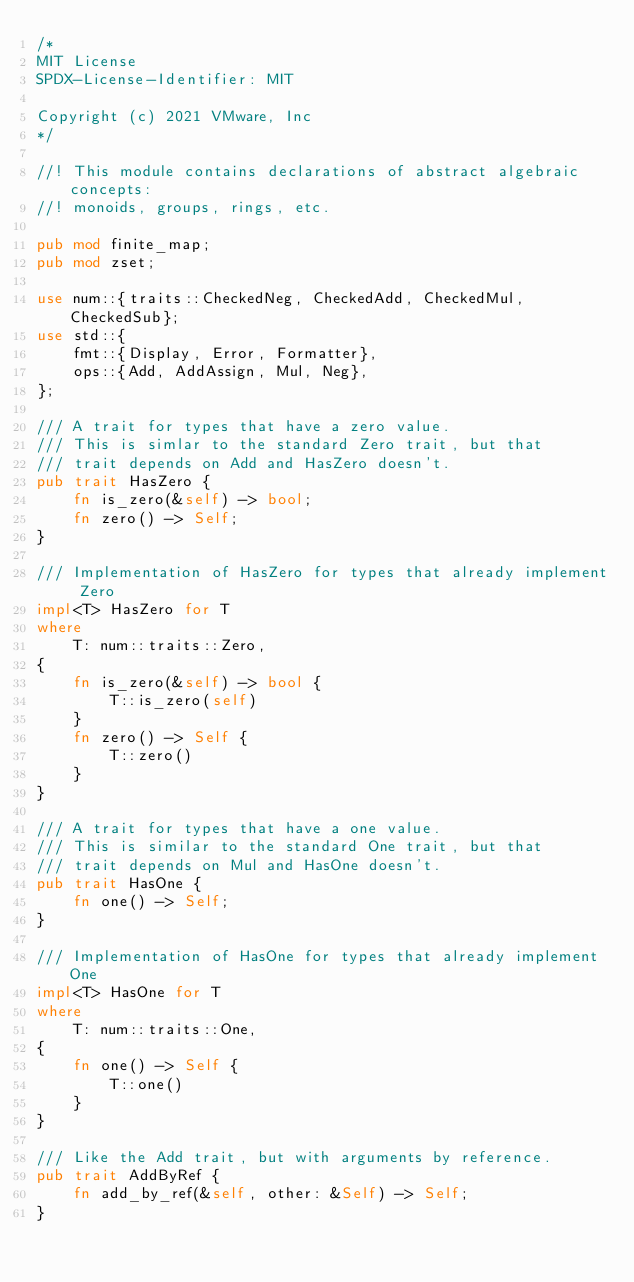Convert code to text. <code><loc_0><loc_0><loc_500><loc_500><_Rust_>/*
MIT License
SPDX-License-Identifier: MIT

Copyright (c) 2021 VMware, Inc
*/

//! This module contains declarations of abstract algebraic concepts:
//! monoids, groups, rings, etc.

pub mod finite_map;
pub mod zset;

use num::{traits::CheckedNeg, CheckedAdd, CheckedMul, CheckedSub};
use std::{
    fmt::{Display, Error, Formatter},
    ops::{Add, AddAssign, Mul, Neg},
};

/// A trait for types that have a zero value.
/// This is simlar to the standard Zero trait, but that
/// trait depends on Add and HasZero doesn't.
pub trait HasZero {
    fn is_zero(&self) -> bool;
    fn zero() -> Self;
}

/// Implementation of HasZero for types that already implement Zero
impl<T> HasZero for T
where
    T: num::traits::Zero,
{
    fn is_zero(&self) -> bool {
        T::is_zero(self)
    }
    fn zero() -> Self {
        T::zero()
    }
}

/// A trait for types that have a one value.
/// This is similar to the standard One trait, but that
/// trait depends on Mul and HasOne doesn't.
pub trait HasOne {
    fn one() -> Self;
}

/// Implementation of HasOne for types that already implement One
impl<T> HasOne for T
where
    T: num::traits::One,
{
    fn one() -> Self {
        T::one()
    }
}

/// Like the Add trait, but with arguments by reference.
pub trait AddByRef {
    fn add_by_ref(&self, other: &Self) -> Self;
}
</code> 